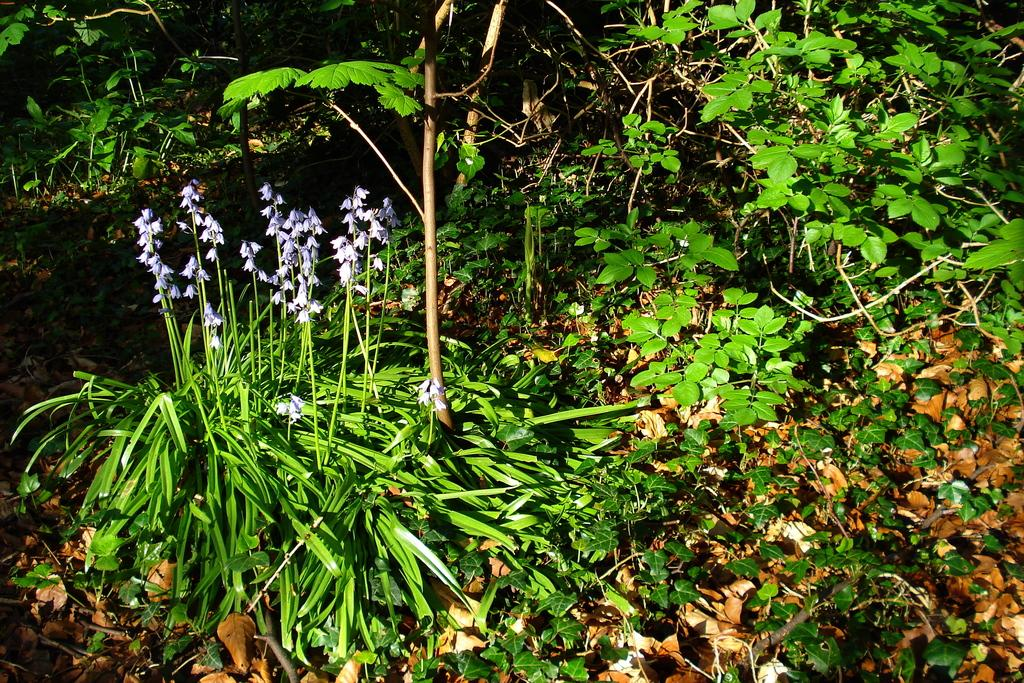What types of vegetation can be seen in the image? There are many plants and flowers in the image. Can you describe the condition of the plants in the image? The plants appear to be healthy, with leaves on the ground. What type of meal is being prepared in the image? There is no meal preparation visible in the image; it features plants and flowers. Can you tell me how many goldfish are swimming in the image? There are no goldfish present in the image; it features plants and flowers. 